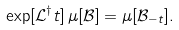<formula> <loc_0><loc_0><loc_500><loc_500>\exp [ \mathcal { L } ^ { \dag } t ] \, \mu [ \mathcal { B } ] = \mu [ \mathcal { B } _ { - t } ] .</formula> 